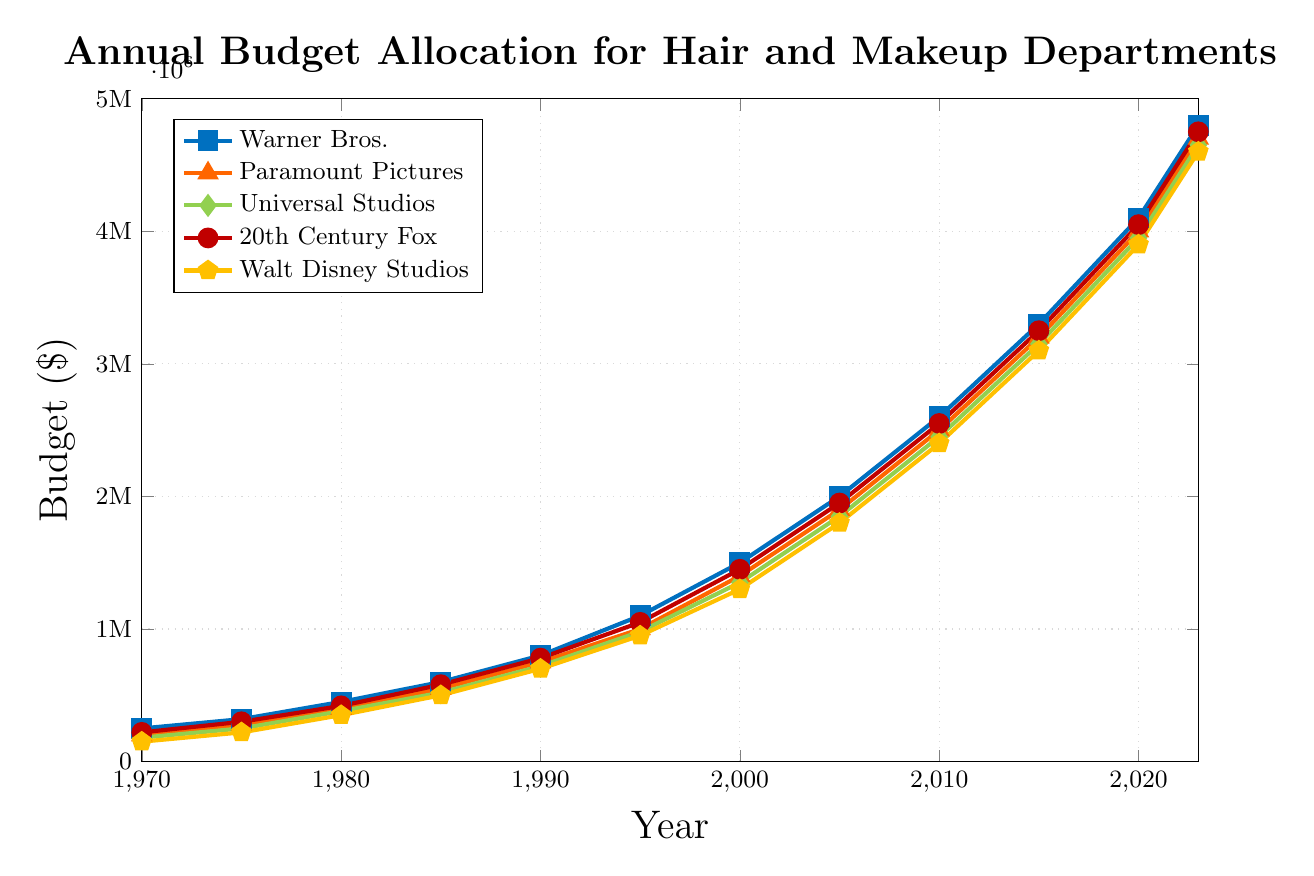Which studio had the highest budget allocation for hair and makeup in 1980? To find the studio with the highest budget allocation in 1980, we look at the budgets for each studio in that year: Warner Bros. - $450,000, Paramount Pictures - $400,000, Universal Studios - $380,000, 20th Century Fox - $420,000, Walt Disney Studios - $350,000. The highest value is $450,000 for Warner Bros.
Answer: Warner Bros How did the budget for Walt Disney Studios compare between 1970 and 2023? To compare the budgets, we find the values for Walt Disney Studios in 1970 and 2023. In 1970, the budget was $150,000, and in 2023, it was $4,600,000.
Answer: The budget increased from $150,000 to $4,600,000 Which year shows the greatest increase in budget for Warner Bros. compared to the previous recorded year? We need to calculate the difference in the budget for Warner Bros. for consecutive recorded years and find the maximum difference. 
1975-1970: $320,000 - $250,000 = $70,000, 
1980-1975: $450,000 - $320,000 = $130,000, 
1985-1980: $600,000 - $450,000 = $150,000, 
1990-1985: $800,000 - $600,000 = $200,000, 
1995-1990: $1,100,000 - $800,000 = $300,000, 
2000-1995: $1,500,000 - $1,100,000 = $400,000, 
2005-2000: $2,000,000 - $1,500,000 = $500,000, 
2010-2005: $2,600,000 - $2,000,000 = $600,000, 
2015-2010: $3,300,000 - $2,600,000 = $700,000. 
2020-2015: $4,100,000 - $3,300,000 = $800,000.
2023-2020 $4,800,000 - $4,100,000 = $700,000. The greatest increase occurred between 2015 and 2020 with a difference of $800,000.
Answer: 2015 to 2020 In which year did 20th Century Fox's budget first exceed $2,000,000? We need to identify the first recorded year when the budget for 20th Century Fox is above $2,000,000. It first exceeds $2,000,000 in 2005 with a budget of $1,950,000.
Answer: 2005 What is the average annual budget allocation for Universal Studios over the entire period? To find the average, sum the budgets for Universal Studios from all years and divide by the number of years. 
(180,000 + 250,000 + 380,000 + 520,000 + 720,000 + 980,000 + 1,350,000 + 1,850,000 + 2,450,000 + 3,150,000 + 3,950,000 + 4,650,000) / 12 = 20,455,000 / 12 = $1,704,583.33 (approx)
Answer: $1,704,583.33 How much more did Warner Bros. allocate to their hair and makeup department compared to Paramount Pictures in 1995? To find the difference, subtract the budget of Paramount Pictures from the budget of Warner Bros: $1,100,000 - $1,000,000 = $100,000.
Answer: $100,000 Which studio consistently had the smallest annual budget allocation throughout the years shown? To find the studio with the smallest budgets over the years, we compare the values for each year. Walt Disney Studios had the smallest values in each year except in 1980 where Universal Studios had a smaller budget (but this is only an exception). Therefore, overall, Walt Disney Studios consistently had the smallest budget.
Answer: Walt Disney Studios What is the total combined budget allocation for all studios in 2023? Add the budget allocations for all studios in 2023: 
$4,800,000 (Warner Bros.) + $4,700,000 (Paramount Pictures) + $4,650,000 (Universal Studios) + $4,750,000 (20th Century Fox) + $4,600,000 (Walt Disney Studios) = $23,500,000.
Answer: $23,500,000 